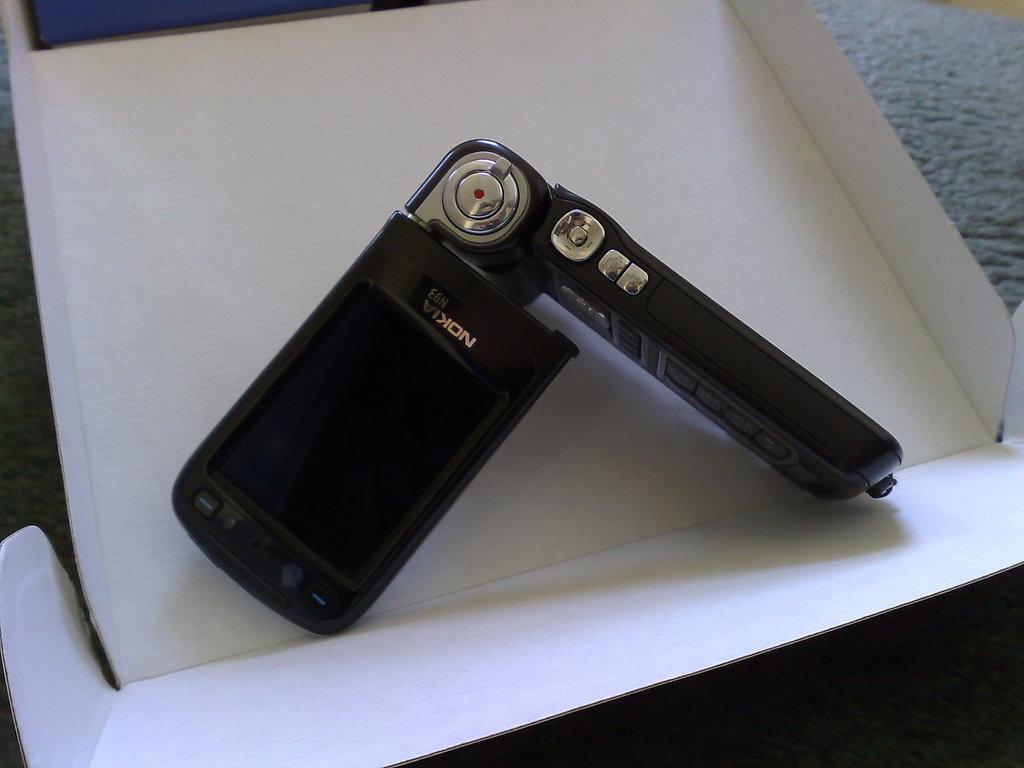How would you summarize this image in a sentence or two? This image is taken indoors. In the background there is a surface. It is gray in color. In the middle of the image there is a mobile phone on the cardboard box. 